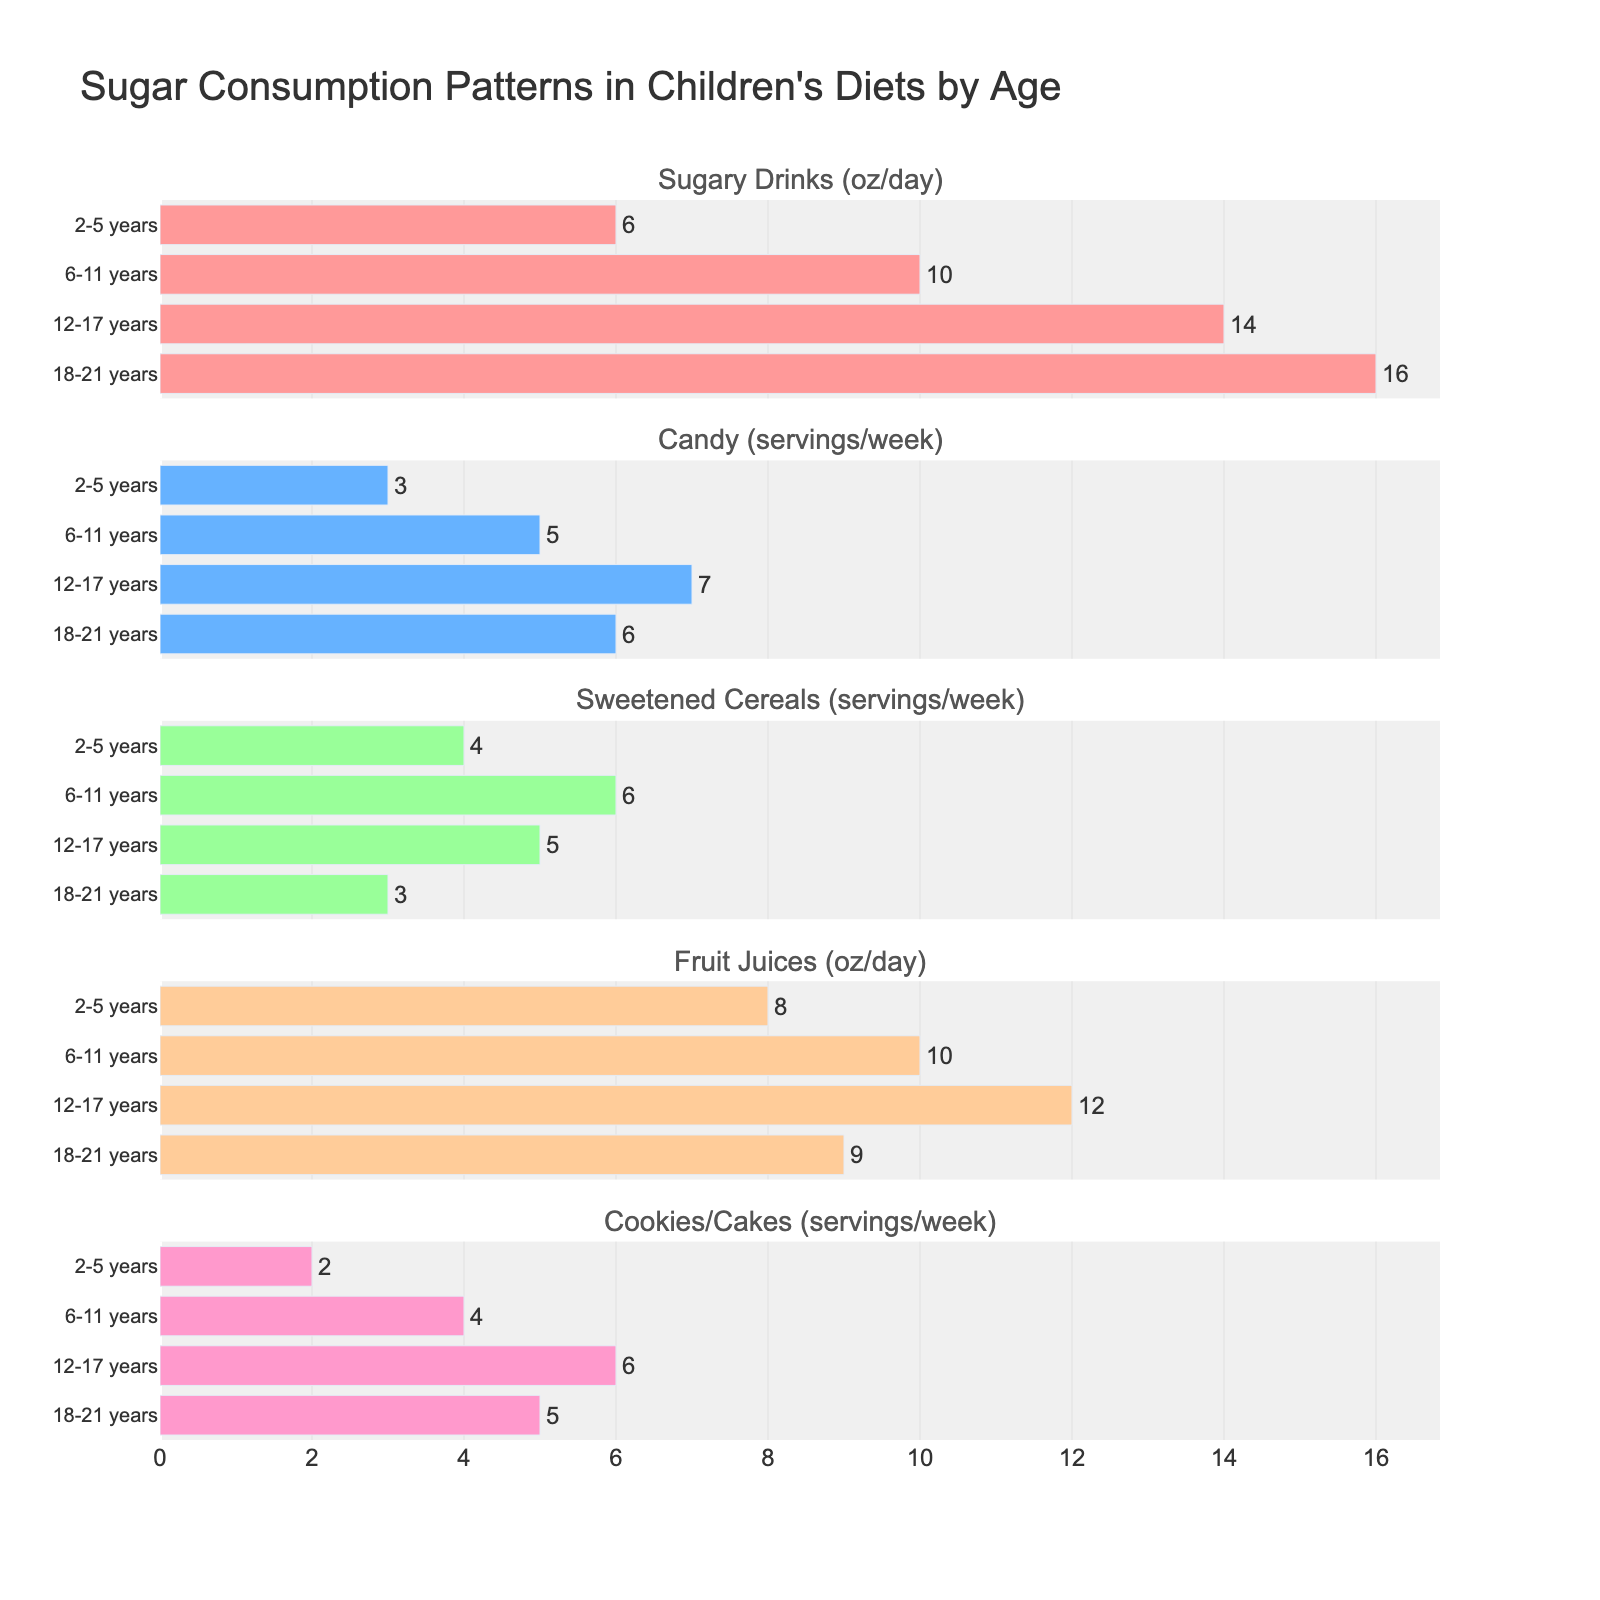What is the title of the figure? The title is located at the top of the figure and is often used to summarize the information presented in the plot. From the given code, the title is "Sugar Consumption Patterns in Children's Diets by Age".
Answer: Sugar Consumption Patterns in Children's Diets by Age Which age group consumes the most sugary drinks per day? By looking at the "Sugary Drinks" subplot, the bar representing the '18-21 years' age group is the longest, indicating they consume the most sugary drinks per day.
Answer: 18-21 years How many servings of candy do children aged 6-11 years consume per week? The subplot for "Candy" shows the length of the bar corresponding to the '6-11 years' age group, and the exact value is written outside the bar. This value is 5 servings per week.
Answer: 5 What is the difference in fruit juice consumption between the youngest and eldest age groups? From the "Fruit Juices" subplot, the '2-5 years' group consumes 8 oz/day while the '18-21 years' group consumes 9 oz/day. The difference is 9 - 8.
Answer: 1 oz/day Which age group has a higher consumption of cookies/cakes: 12-17 years or 6-11 years? By comparing the length of bars in the "Cookies/Cakes" subplot for both age groups, the '12-17 years' group has a bar with a value of 6, and the '6-11 years' group has a bar with a value of 4.
Answer: 12-17 years Among all age groups, which one consumes the least amount of sweetened cereals per week? From the "Sweetened Cereals" subplot, the '18-21 years' age group has the shortest bar indicating the least consumption with a value of 3 servings per week.
Answer: 18-21 years What is the average consumption of candy across all age groups? The values for candy consumption are 3, 5, 7, and 6 for '2-5 years', '6-11 years', '12-17 years', and '18-21 years' respectively. The average is calculated as (3 + 5 + 7 + 6) / 4.
Answer: 5.25 servings/week Compare the sugary drinks and fruit juices consumption for the 12-17 years age group. In the subplots for "Sugary Drinks" and "Fruit Juices", the '12-17 years' group consumes 14 oz/day of sugary drinks and 12 oz/day of fruit juices.
Answer: 14 oz/day vs. 12 oz/day What is the total number of servings of sweetened cereals consumed per week by children aged 2-17 years? Summing the sweetened cereal values for the age groups 2-5 years (4), 6-11 years (6), and 12-17 years (5): 4 + 6 + 5.
Answer: 15 servings/week 